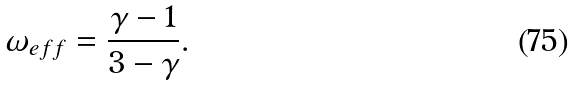<formula> <loc_0><loc_0><loc_500><loc_500>\omega _ { e f f } = \frac { \gamma - 1 } { 3 - \gamma } .</formula> 